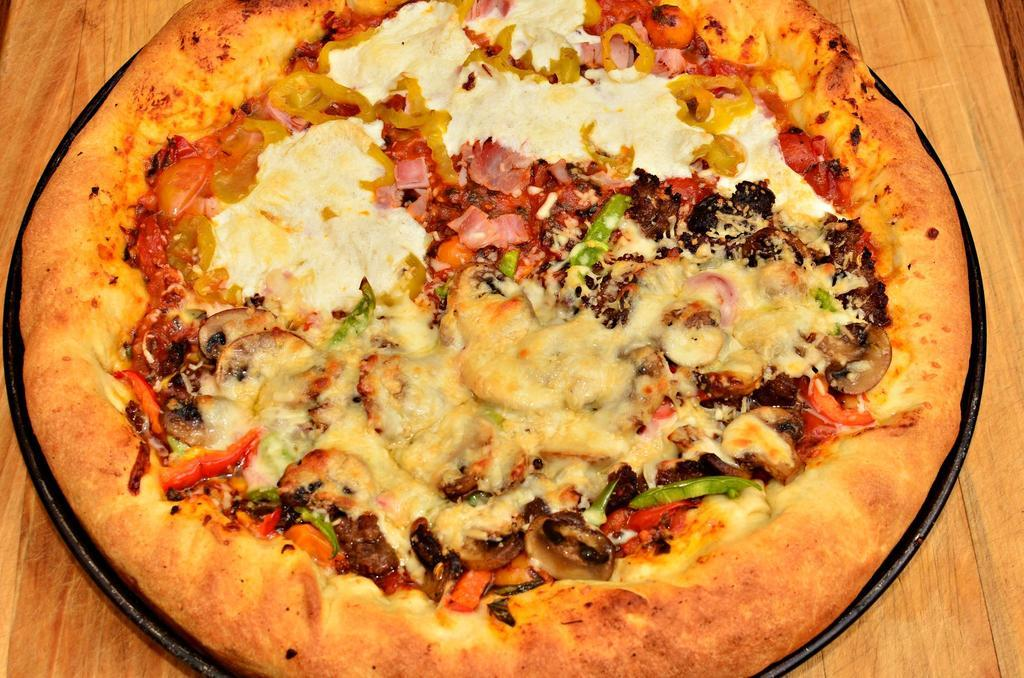What type of food is shown in the image? There is a pizza in the image. How is the pizza presented? The pizza is in a plate. Where is the plate with pizza located? The plate with pizza is placed on a table. How many ducks are swimming in the pizza in the image? There are no ducks present in the image, and the pizza is not a body of water for ducks to swim in. 